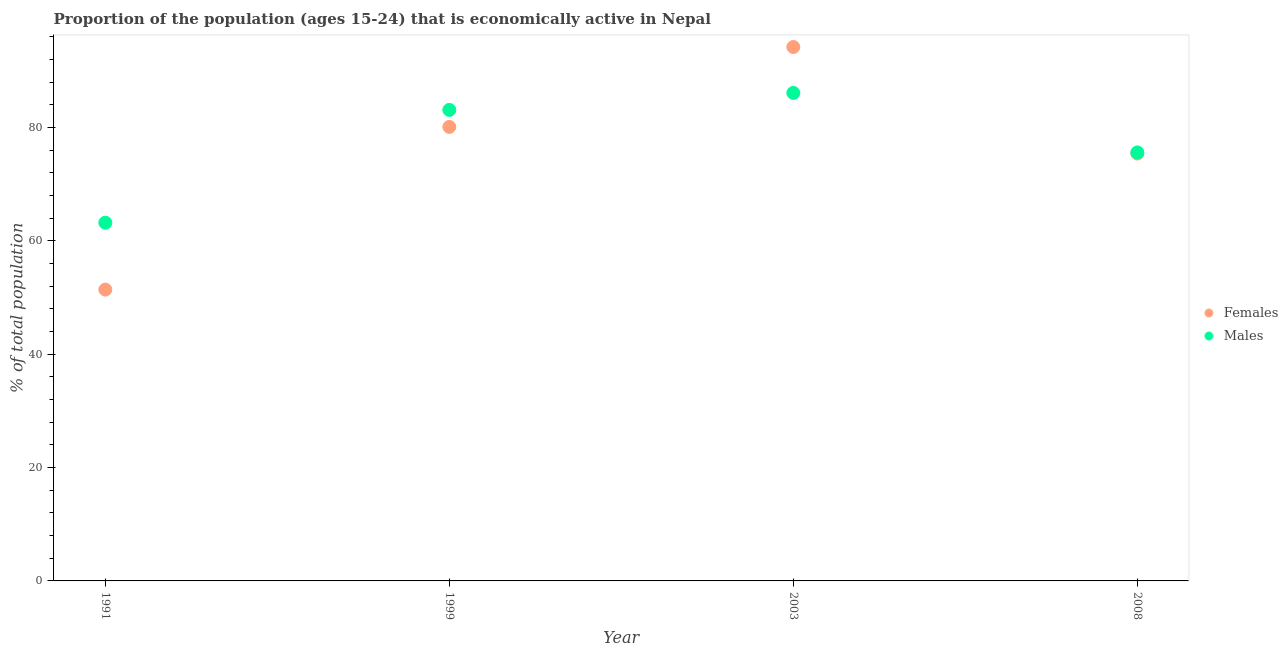How many different coloured dotlines are there?
Keep it short and to the point. 2. What is the percentage of economically active female population in 1991?
Provide a short and direct response. 51.4. Across all years, what is the maximum percentage of economically active female population?
Provide a short and direct response. 94.2. Across all years, what is the minimum percentage of economically active male population?
Your response must be concise. 63.2. In which year was the percentage of economically active male population minimum?
Offer a very short reply. 1991. What is the total percentage of economically active male population in the graph?
Your answer should be compact. 308. What is the difference between the percentage of economically active male population in 1999 and that in 2003?
Keep it short and to the point. -3. What is the difference between the percentage of economically active female population in 1999 and the percentage of economically active male population in 2008?
Give a very brief answer. 4.5. What is the average percentage of economically active female population per year?
Provide a short and direct response. 75.27. In the year 1991, what is the difference between the percentage of economically active female population and percentage of economically active male population?
Offer a terse response. -11.8. What is the ratio of the percentage of economically active female population in 2003 to that in 2008?
Your response must be concise. 1.25. What is the difference between the highest and the second highest percentage of economically active male population?
Provide a succinct answer. 3. What is the difference between the highest and the lowest percentage of economically active male population?
Your answer should be compact. 22.9. Does the percentage of economically active female population monotonically increase over the years?
Your answer should be very brief. No. Is the percentage of economically active male population strictly greater than the percentage of economically active female population over the years?
Make the answer very short. No. How many years are there in the graph?
Your answer should be very brief. 4. What is the difference between two consecutive major ticks on the Y-axis?
Your response must be concise. 20. Are the values on the major ticks of Y-axis written in scientific E-notation?
Keep it short and to the point. No. Does the graph contain grids?
Your answer should be very brief. No. What is the title of the graph?
Give a very brief answer. Proportion of the population (ages 15-24) that is economically active in Nepal. What is the label or title of the X-axis?
Provide a succinct answer. Year. What is the label or title of the Y-axis?
Offer a terse response. % of total population. What is the % of total population in Females in 1991?
Ensure brevity in your answer.  51.4. What is the % of total population in Males in 1991?
Make the answer very short. 63.2. What is the % of total population of Females in 1999?
Your answer should be very brief. 80.1. What is the % of total population of Males in 1999?
Give a very brief answer. 83.1. What is the % of total population of Females in 2003?
Your response must be concise. 94.2. What is the % of total population in Males in 2003?
Give a very brief answer. 86.1. What is the % of total population of Females in 2008?
Your response must be concise. 75.4. What is the % of total population of Males in 2008?
Make the answer very short. 75.6. Across all years, what is the maximum % of total population of Females?
Ensure brevity in your answer.  94.2. Across all years, what is the maximum % of total population in Males?
Your answer should be compact. 86.1. Across all years, what is the minimum % of total population in Females?
Provide a succinct answer. 51.4. Across all years, what is the minimum % of total population of Males?
Give a very brief answer. 63.2. What is the total % of total population of Females in the graph?
Make the answer very short. 301.1. What is the total % of total population in Males in the graph?
Provide a short and direct response. 308. What is the difference between the % of total population of Females in 1991 and that in 1999?
Ensure brevity in your answer.  -28.7. What is the difference between the % of total population in Males in 1991 and that in 1999?
Provide a short and direct response. -19.9. What is the difference between the % of total population of Females in 1991 and that in 2003?
Offer a very short reply. -42.8. What is the difference between the % of total population in Males in 1991 and that in 2003?
Provide a succinct answer. -22.9. What is the difference between the % of total population in Females in 1991 and that in 2008?
Offer a very short reply. -24. What is the difference between the % of total population of Females in 1999 and that in 2003?
Your answer should be very brief. -14.1. What is the difference between the % of total population in Males in 1999 and that in 2003?
Make the answer very short. -3. What is the difference between the % of total population in Females in 1999 and that in 2008?
Your answer should be very brief. 4.7. What is the difference between the % of total population in Males in 1999 and that in 2008?
Offer a very short reply. 7.5. What is the difference between the % of total population of Males in 2003 and that in 2008?
Your answer should be very brief. 10.5. What is the difference between the % of total population in Females in 1991 and the % of total population in Males in 1999?
Give a very brief answer. -31.7. What is the difference between the % of total population in Females in 1991 and the % of total population in Males in 2003?
Your answer should be compact. -34.7. What is the difference between the % of total population in Females in 1991 and the % of total population in Males in 2008?
Offer a terse response. -24.2. What is the difference between the % of total population in Females in 1999 and the % of total population in Males in 2003?
Keep it short and to the point. -6. What is the difference between the % of total population in Females in 2003 and the % of total population in Males in 2008?
Provide a succinct answer. 18.6. What is the average % of total population in Females per year?
Your response must be concise. 75.28. What is the average % of total population in Males per year?
Give a very brief answer. 77. In the year 1991, what is the difference between the % of total population in Females and % of total population in Males?
Your response must be concise. -11.8. In the year 1999, what is the difference between the % of total population of Females and % of total population of Males?
Provide a succinct answer. -3. In the year 2003, what is the difference between the % of total population in Females and % of total population in Males?
Ensure brevity in your answer.  8.1. What is the ratio of the % of total population in Females in 1991 to that in 1999?
Offer a very short reply. 0.64. What is the ratio of the % of total population in Males in 1991 to that in 1999?
Your response must be concise. 0.76. What is the ratio of the % of total population of Females in 1991 to that in 2003?
Provide a short and direct response. 0.55. What is the ratio of the % of total population of Males in 1991 to that in 2003?
Keep it short and to the point. 0.73. What is the ratio of the % of total population of Females in 1991 to that in 2008?
Your answer should be compact. 0.68. What is the ratio of the % of total population of Males in 1991 to that in 2008?
Your answer should be compact. 0.84. What is the ratio of the % of total population of Females in 1999 to that in 2003?
Your answer should be very brief. 0.85. What is the ratio of the % of total population in Males in 1999 to that in 2003?
Your response must be concise. 0.97. What is the ratio of the % of total population of Females in 1999 to that in 2008?
Your answer should be compact. 1.06. What is the ratio of the % of total population in Males in 1999 to that in 2008?
Your answer should be compact. 1.1. What is the ratio of the % of total population of Females in 2003 to that in 2008?
Ensure brevity in your answer.  1.25. What is the ratio of the % of total population in Males in 2003 to that in 2008?
Ensure brevity in your answer.  1.14. What is the difference between the highest and the second highest % of total population of Males?
Your answer should be compact. 3. What is the difference between the highest and the lowest % of total population of Females?
Your answer should be very brief. 42.8. What is the difference between the highest and the lowest % of total population of Males?
Provide a succinct answer. 22.9. 